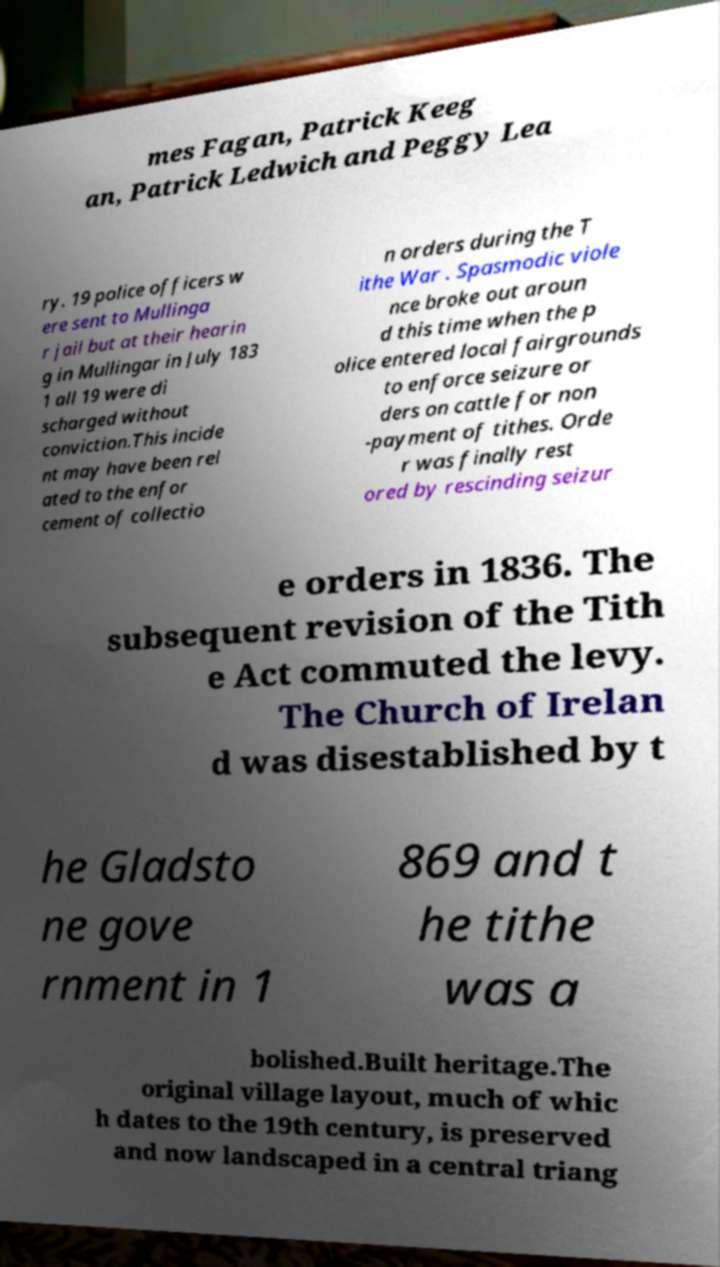Can you accurately transcribe the text from the provided image for me? mes Fagan, Patrick Keeg an, Patrick Ledwich and Peggy Lea ry. 19 police officers w ere sent to Mullinga r jail but at their hearin g in Mullingar in July 183 1 all 19 were di scharged without conviction.This incide nt may have been rel ated to the enfor cement of collectio n orders during the T ithe War . Spasmodic viole nce broke out aroun d this time when the p olice entered local fairgrounds to enforce seizure or ders on cattle for non -payment of tithes. Orde r was finally rest ored by rescinding seizur e orders in 1836. The subsequent revision of the Tith e Act commuted the levy. The Church of Irelan d was disestablished by t he Gladsto ne gove rnment in 1 869 and t he tithe was a bolished.Built heritage.The original village layout, much of whic h dates to the 19th century, is preserved and now landscaped in a central triang 